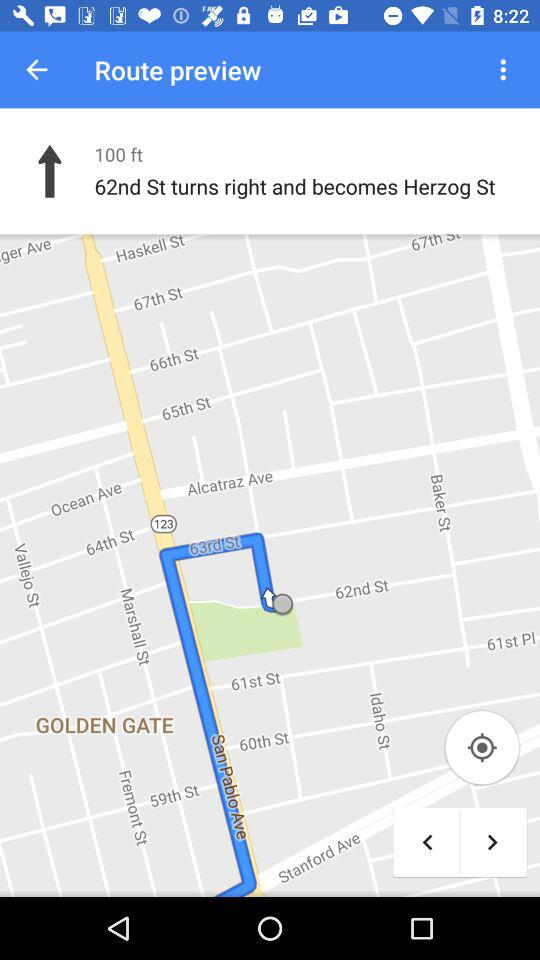How many feet are there between the two streets?
Answer the question using a single word or phrase. 100 